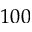Convert formula to latex. <formula><loc_0><loc_0><loc_500><loc_500>1 0 0</formula> 